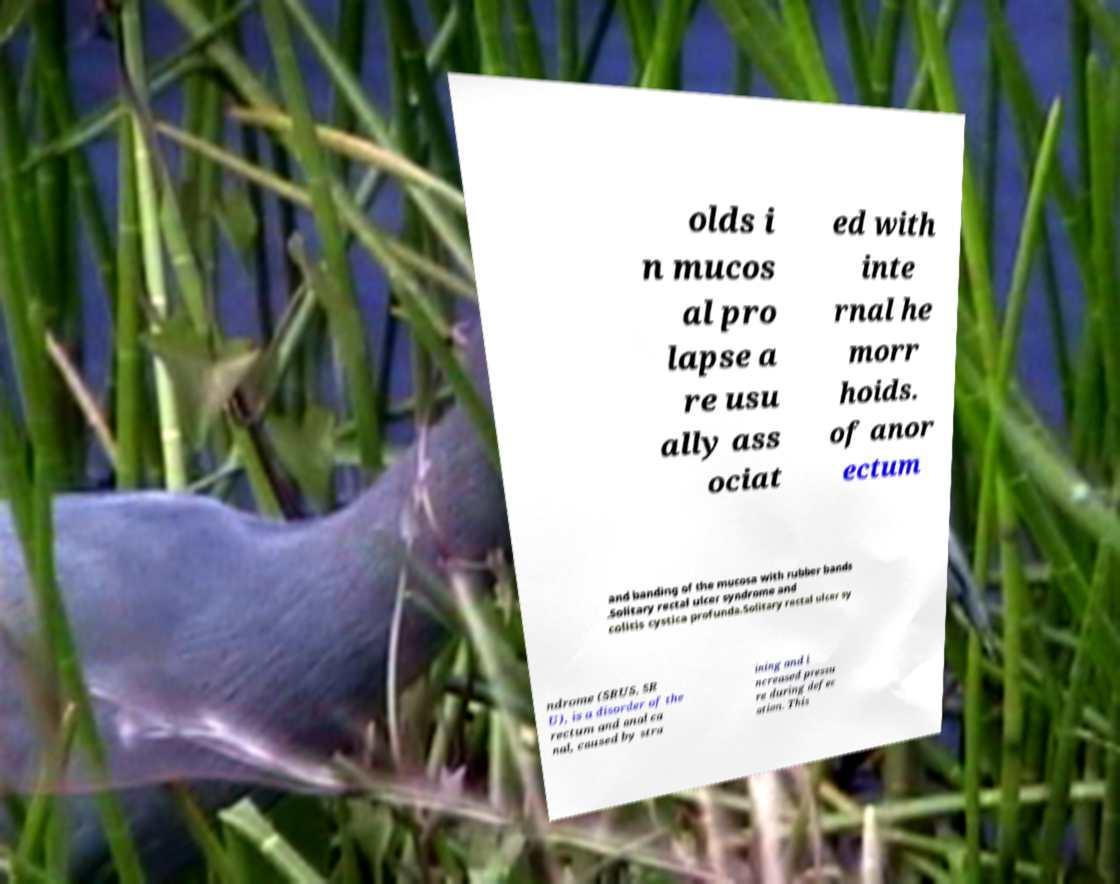Please read and relay the text visible in this image. What does it say? olds i n mucos al pro lapse a re usu ally ass ociat ed with inte rnal he morr hoids. of anor ectum and banding of the mucosa with rubber bands .Solitary rectal ulcer syndrome and colitis cystica profunda.Solitary rectal ulcer sy ndrome (SRUS, SR U), is a disorder of the rectum and anal ca nal, caused by stra ining and i ncreased pressu re during defec ation. This 